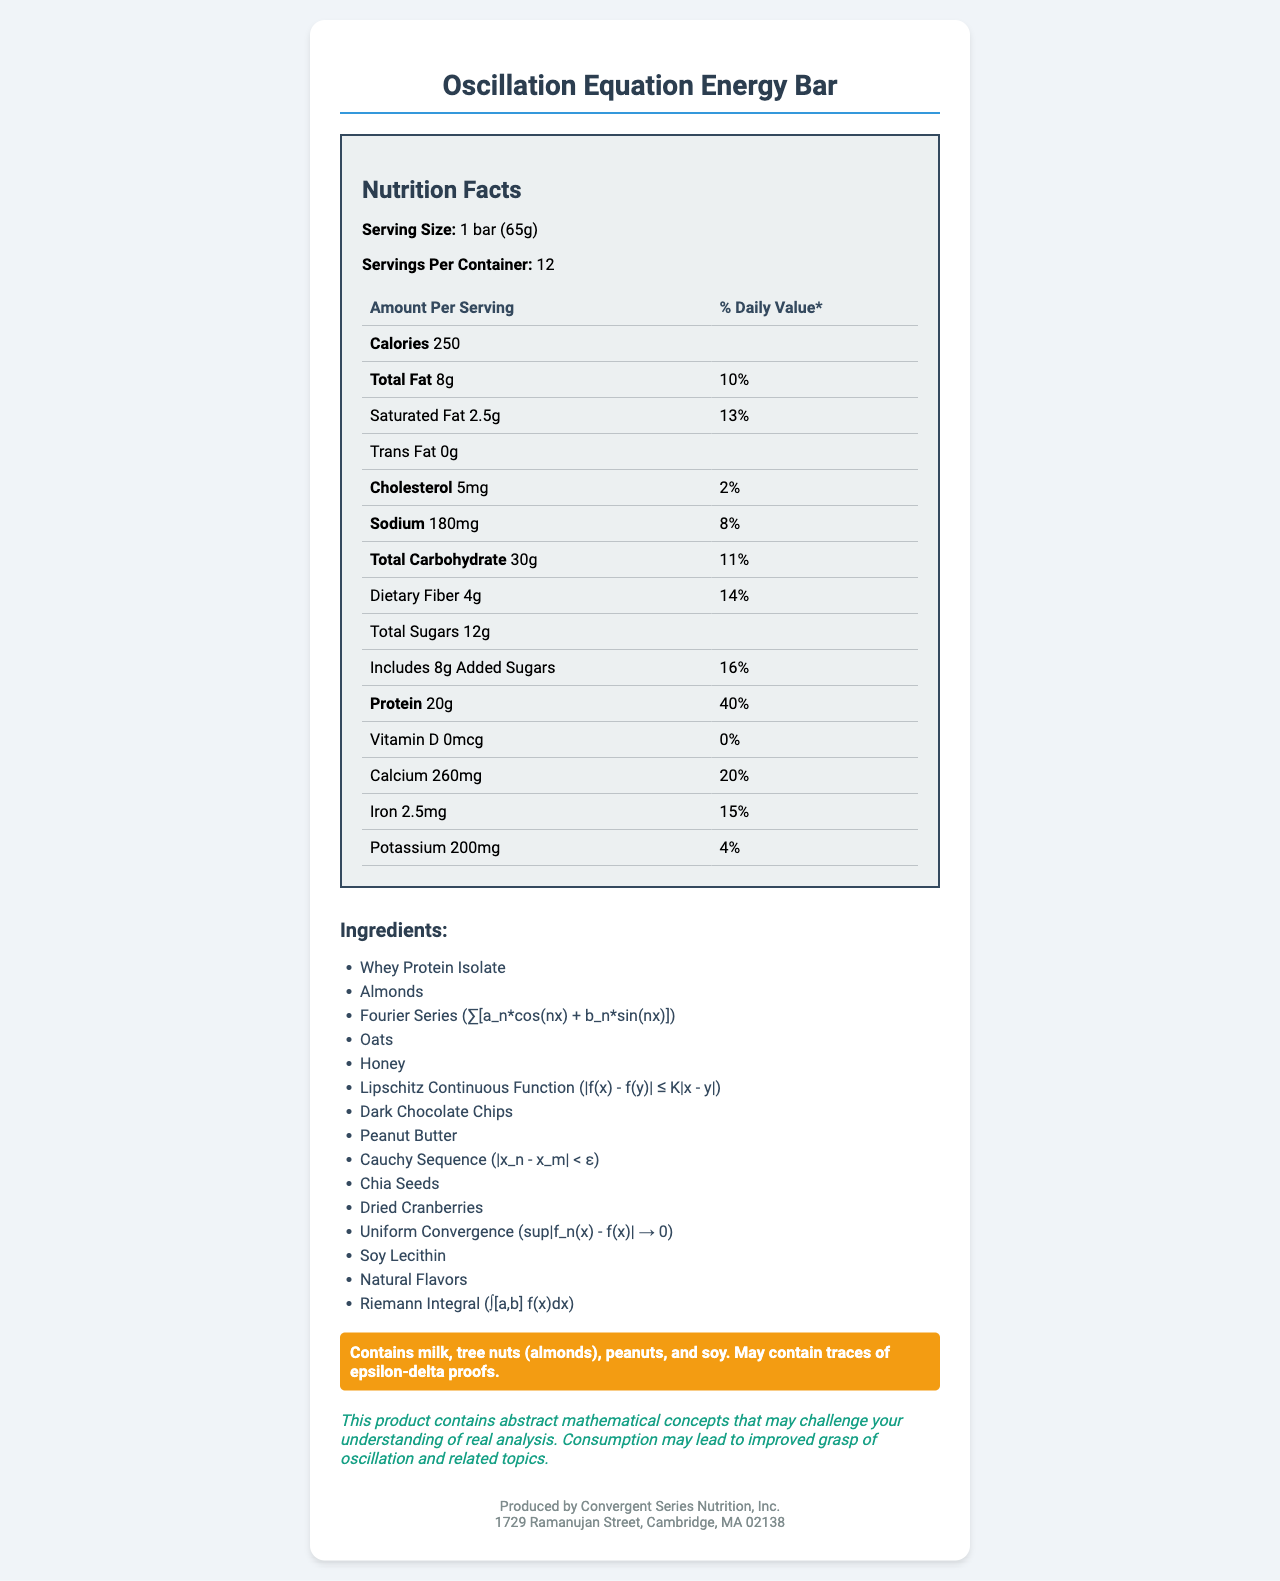What is the serving size of the Oscillation Equation Energy Bar? The serving size is clearly mentioned as "1 bar (65g)" in the document.
Answer: 1 bar (65g) How many servings are there per container? The document states there are 12 servings per container.
Answer: 12 What is the total fat content per serving? The document lists the total fat content as "8g" per serving.
Answer: 8g What is the amount of protein per serving? The document indicates that each serving contains "20g" of protein.
Answer: 20g How many grams of saturated fat are there in one serving? The saturated fat content per serving is listed as "2.5g".
Answer: 2.5g What is the Cholesterol content in the Oscillation Equation Energy Bar per serving? The document lists the cholesterol content as "5mg" per serving.
Answer: 5mg How much added sugars does each serving contain? Each serving includes "8g" of added sugars as per the document.
Answer: 8g How much calcium is provided per serving and what is its daily value percentage? The document states that each serving contains "260mg" of calcium, which is "20%" of the daily value.
Answer: 260mg, 20% Which of the following is NOT an ingredient in the Oscillation Equation Energy Bar? 
A. Chia Seeds
B. Fourier Series
C. Magnesium
D. Riemann Integral Chia Seeds, Fourier Series, and Riemann Integral are listed as ingredients, while Magnesium is not.
Answer: C. Magnesium What percentage of the daily value of dietary fiber does one serving contain? The document lists the dietary fiber content as "14%" of the daily value per serving.
Answer: 14% Which of the following is true about the Oscillation Equation Energy Bar?
I. Contains 200mg of potassium per serving
II. Contains 20g of protein per serving
III. Contains 2mg of iron per serving
A. I only
B. II only
C. I and II
D. I and III The document confirms that it contains "200mg of potassium" and "20g of protein" per serving. It contains "2.5mg" of iron, not "2mg".
Answer: C. I and II Does the Oscillation Equation Energy Bar contain any vitamin D? The document lists vitamin D content as "0mcg", indicating there is no vitamin D.
Answer: No Summarize the main details provided in the document. The document provides both nutritional information and a list of ingredients for the Energy Bar, highlighting some unique mathematical components.
Answer: The Oscillation Equation Energy Bar is a protein bar with various ingredients, including mathematical formulas. Each bar serving size is 65g, with 12 servings per container, and contains 250 calories. The bar has nutritional components like 8g of total fat, 20g of protein, and various vitamins and minerals. It includes unique mathematical ingredients like Fourier Series and Riemann Integral. The allergen warning notes the presence of milk, tree nuts, peanuts, and soy. Can I determine the exact price of one bar from the information given in the document? The document does not provide any pricing information.
Answer: Not enough information 